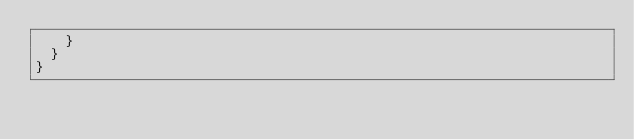Convert code to text. <code><loc_0><loc_0><loc_500><loc_500><_C#_>		}
	}
}</code> 